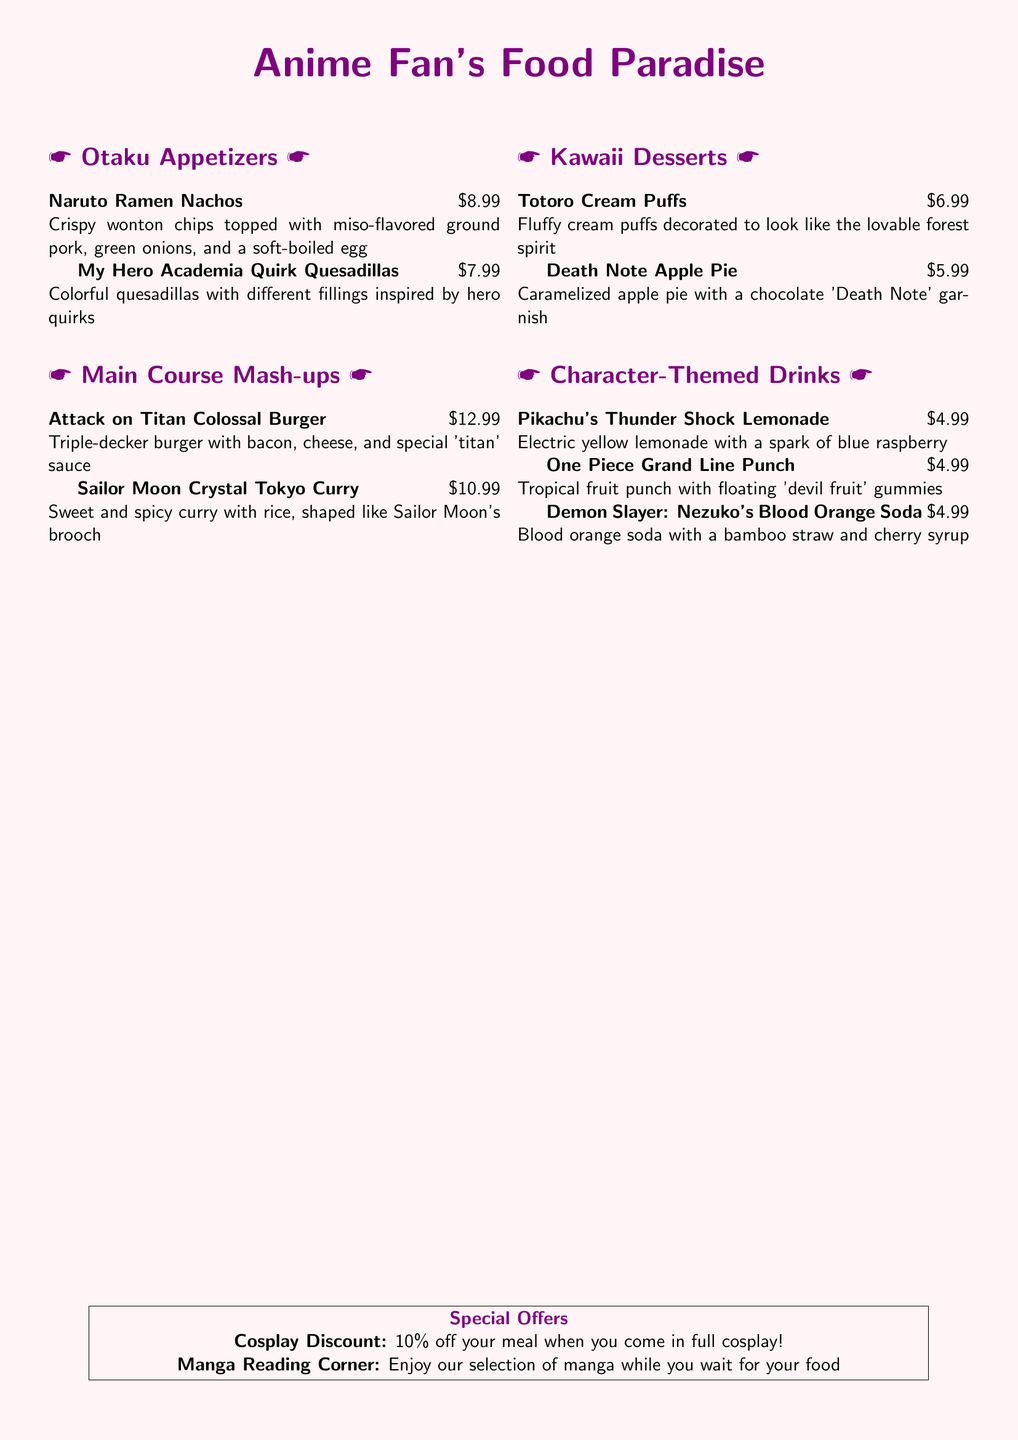what is the price of Naruto Ramen Nachos? The price of Naruto Ramen Nachos is listed next to the dish on the menu.
Answer: $8.99 what dish features a bamboo straw? The menu describes a drink that includes a bamboo straw, which is associated with a specific character.
Answer: Nezuko's Blood Orange Soda how much is the Sailor Moon Crystal Tokyo Curry? The price for the Sailor Moon Crystal Tokyo Curry is mentioned in the price list.
Answer: $10.99 what character is the Death Note Apple Pie inspired by? The name of the dessert indicates it is inspired by a well-known series.
Answer: Death Note how much discount do you get for cosplaying? The menu lists a specific discount for those in cosplay.
Answer: 10% what is the main ingredient in the Attack on Titan Colossal Burger? The description of the burger includes key components that stand out as main ingredients.
Answer: bacon what type of drink is Pikachu's Thunder Shock Lemonade? The menu specifies the type of beverage being offered with its distinct name.
Answer: lemonade how many appetizers are listed on the menu? By counting the appetizers section, we can determine the number of different dishes offered.
Answer: 2 what flavor is the One Piece Grand Line Punch? The drink's name provides clues to its taste profile.
Answer: tropical fruit 